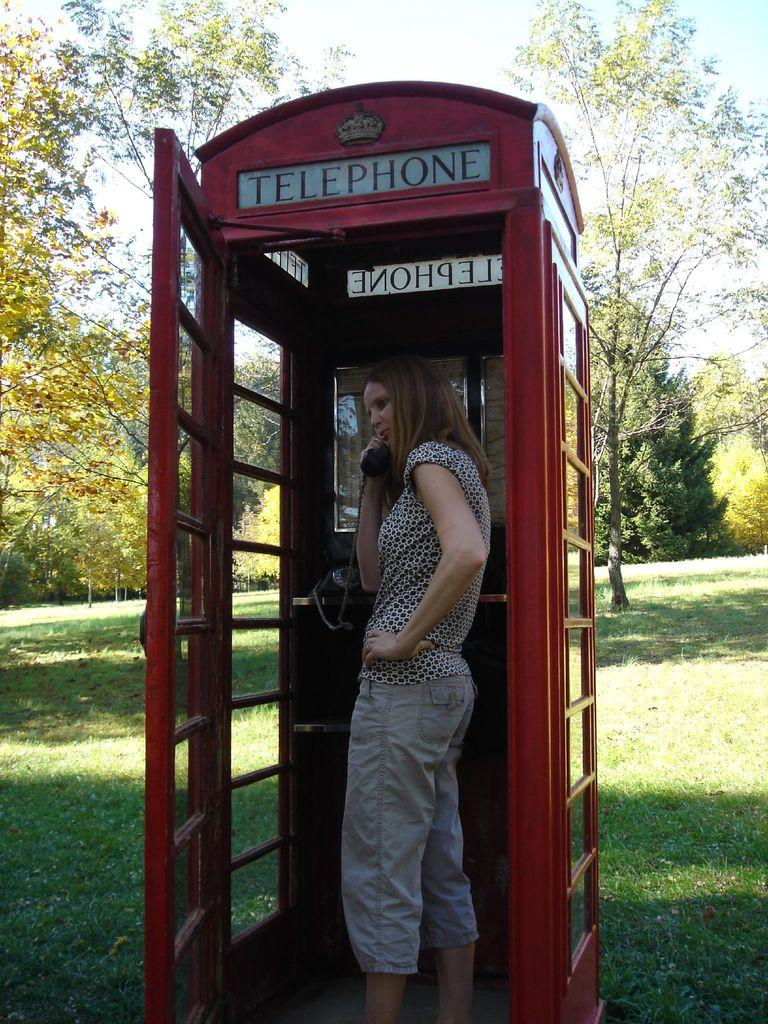Who is the main subject in the image? There is a girl in the image. What is the girl doing in the image? The girl is standing in a telephone booth and holding a telephone. What can be seen in the background of the image? There is grass, trees, and the sky visible in the image. What type of question is the girl asking the robin in the image? There is no robin present in the image, so it is not possible to answer that question. 